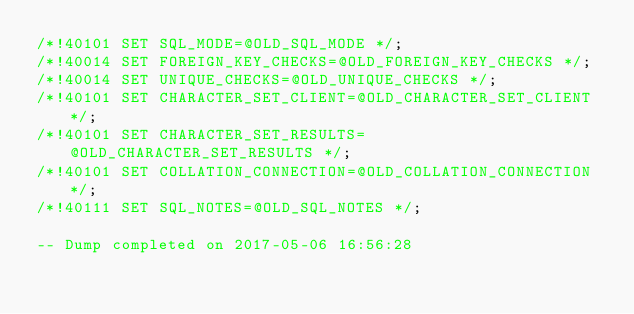<code> <loc_0><loc_0><loc_500><loc_500><_SQL_>/*!40101 SET SQL_MODE=@OLD_SQL_MODE */;
/*!40014 SET FOREIGN_KEY_CHECKS=@OLD_FOREIGN_KEY_CHECKS */;
/*!40014 SET UNIQUE_CHECKS=@OLD_UNIQUE_CHECKS */;
/*!40101 SET CHARACTER_SET_CLIENT=@OLD_CHARACTER_SET_CLIENT */;
/*!40101 SET CHARACTER_SET_RESULTS=@OLD_CHARACTER_SET_RESULTS */;
/*!40101 SET COLLATION_CONNECTION=@OLD_COLLATION_CONNECTION */;
/*!40111 SET SQL_NOTES=@OLD_SQL_NOTES */;

-- Dump completed on 2017-05-06 16:56:28
</code> 